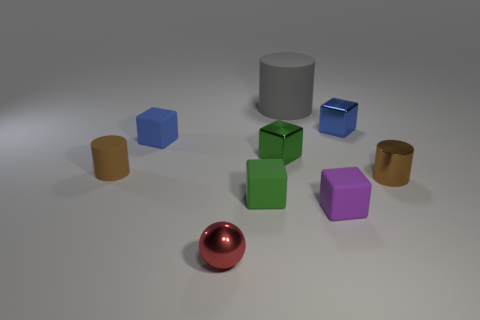How does the light source affect the appearance of the objects in this image? The light source creates a soft shadow on the side of the objects opposite to the light, accentuating their three-dimensional form. It also highlights the reflective properties of the metallic objects, such as the red sphere, making them stand out. 